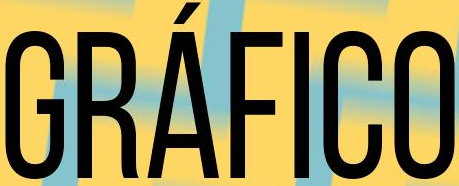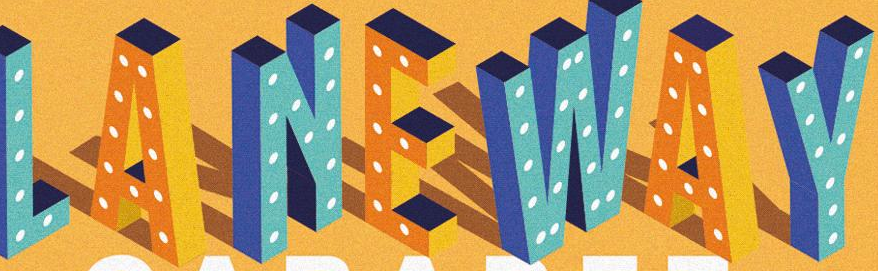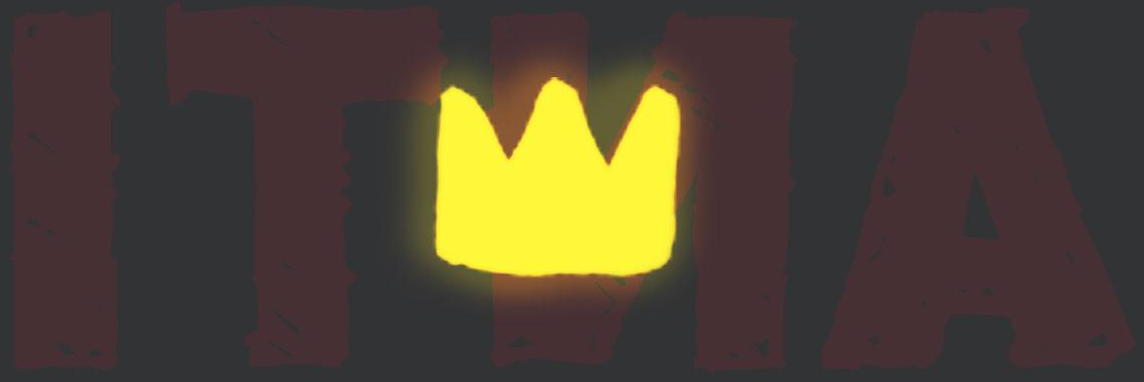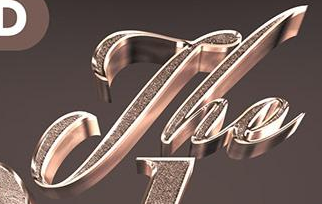Transcribe the words shown in these images in order, separated by a semicolon. GRÁFICO; LANEWAY; ITNA; The 